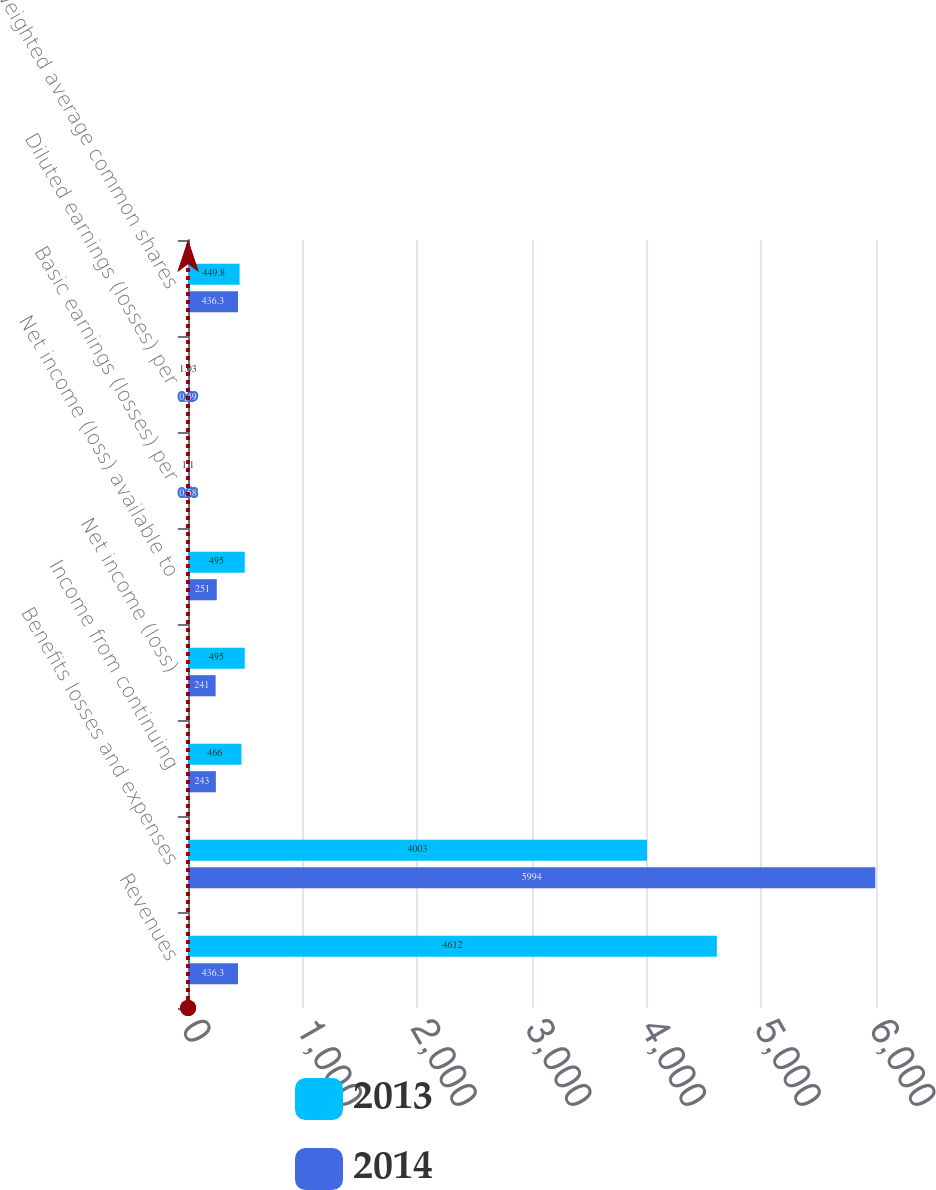<chart> <loc_0><loc_0><loc_500><loc_500><stacked_bar_chart><ecel><fcel>Revenues<fcel>Benefits losses and expenses<fcel>Income from continuing<fcel>Net income (loss)<fcel>Net income (loss) available to<fcel>Basic earnings (losses) per<fcel>Diluted earnings (losses) per<fcel>Weighted average common shares<nl><fcel>2013<fcel>4612<fcel>4003<fcel>466<fcel>495<fcel>495<fcel>1.1<fcel>1.03<fcel>449.8<nl><fcel>2014<fcel>436.3<fcel>5994<fcel>243<fcel>241<fcel>251<fcel>0.58<fcel>0.49<fcel>436.3<nl></chart> 